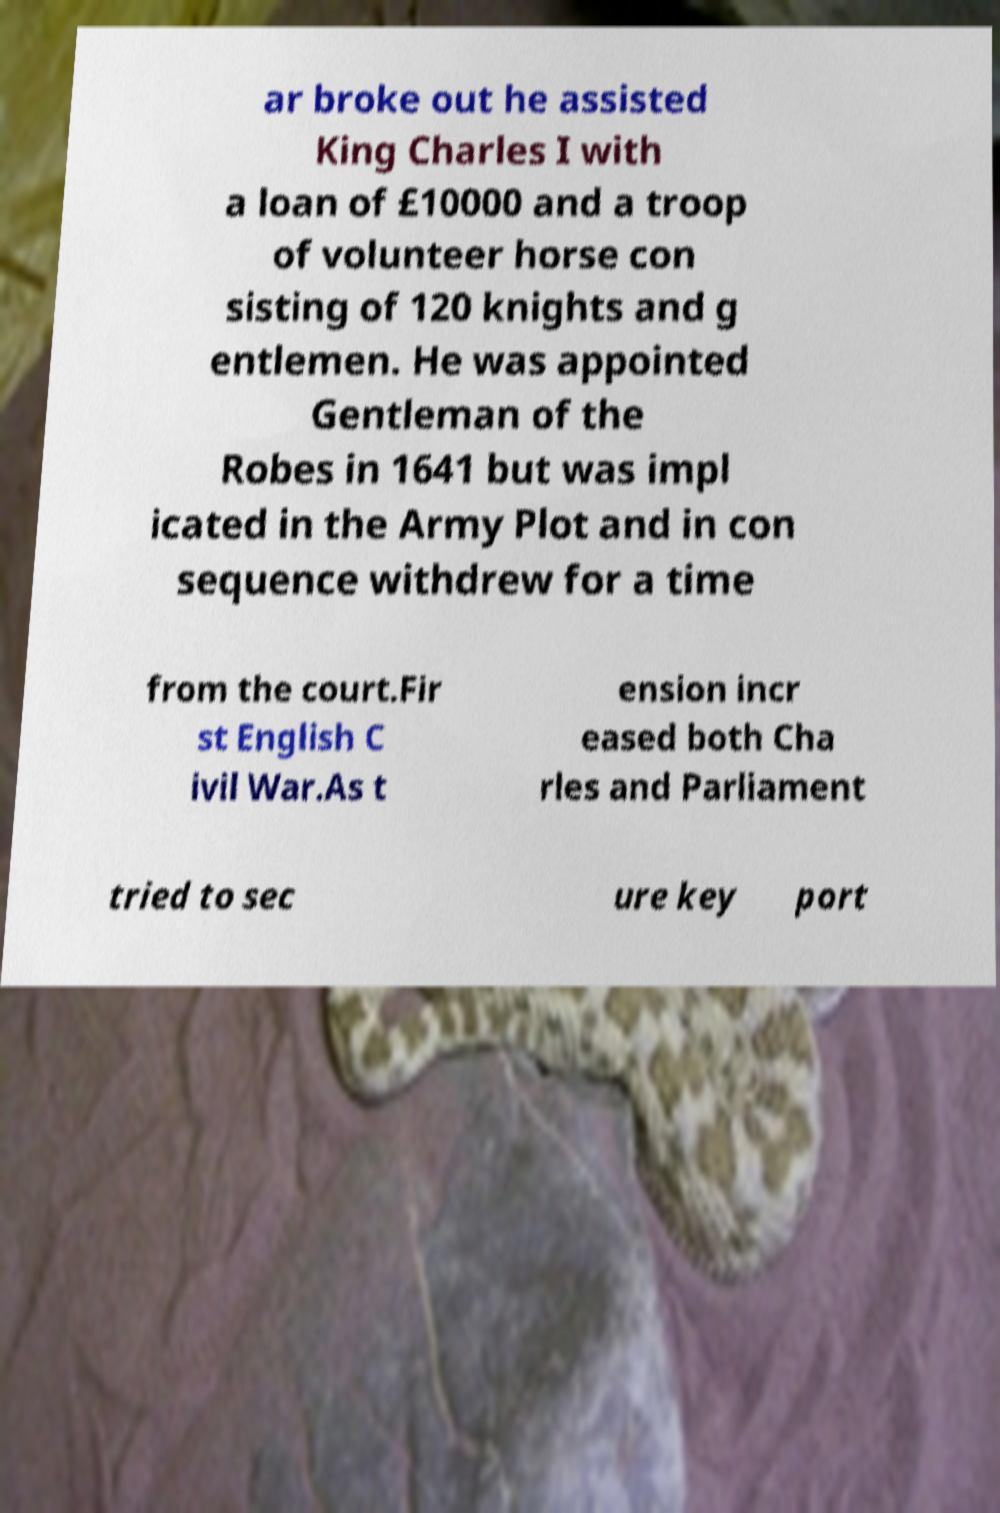There's text embedded in this image that I need extracted. Can you transcribe it verbatim? ar broke out he assisted King Charles I with a loan of £10000 and a troop of volunteer horse con sisting of 120 knights and g entlemen. He was appointed Gentleman of the Robes in 1641 but was impl icated in the Army Plot and in con sequence withdrew for a time from the court.Fir st English C ivil War.As t ension incr eased both Cha rles and Parliament tried to sec ure key port 